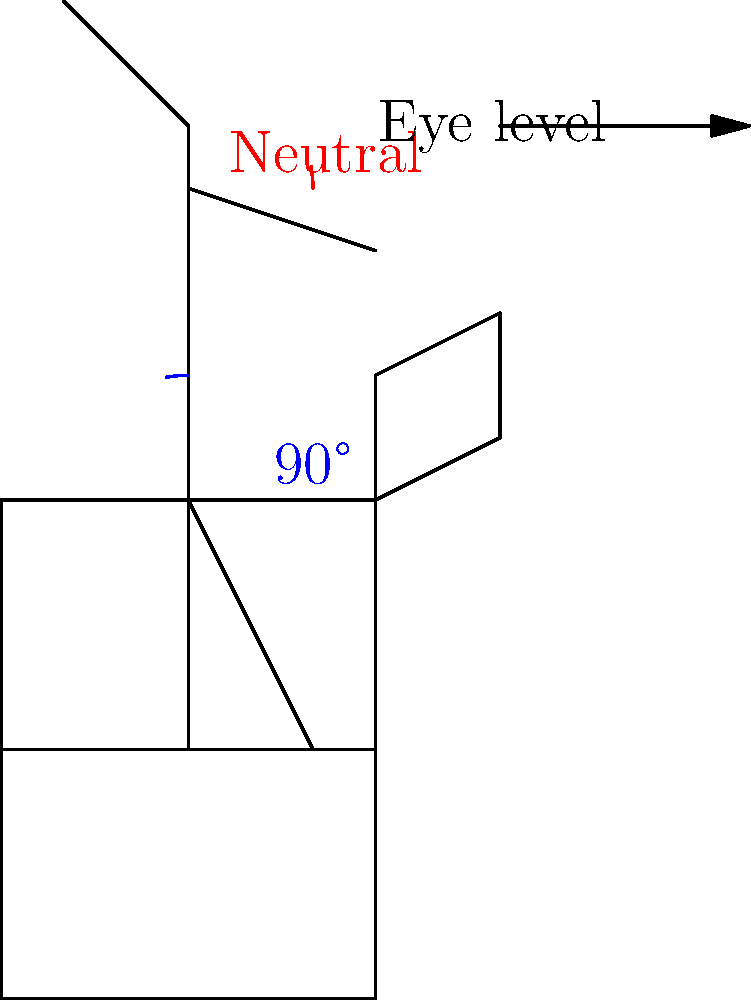As a retired English teacher who enjoys reading classic literature, you understand the importance of maintaining proper posture while engrossed in a book. Based on the diagram, which depicts ideal reading posture, what are the two key angles that should be maintained for optimal biomechanical alignment? To understand the proper posture for reading, let's analyze the diagram step-by-step:

1. Seated position: The figure is seated with the back against the chair for support.

2. Lower body alignment: The hips and knees are bent at approximately 90 degrees, as indicated by the blue angle in the diagram. This position helps distribute weight evenly and reduces strain on the lower back.

3. Spine alignment: The spine is straight and supported by the chair back, maintaining its natural curves.

4. Head position: The head is in a neutral position, with the neck at a slight forward angle (indicated by the red angle). This allows for a relaxed viewing of the book without straining the neck muscles.

5. Book position: The book is held at eye level, reducing the need to tilt the head downward excessively.

The two key angles highlighted in the diagram are:

a) The 90-degree angle at the hips and knees (blue)
b) The slight forward tilt of the head, maintaining a neutral neck position (red)

These angles are crucial for maintaining proper biomechanical alignment while reading, as they help distribute weight evenly, reduce strain on the spine and neck, and allow for comfortable, extended reading sessions without causing undue fatigue or potential long-term postural issues.
Answer: 90-degree hip/knee angle and neutral neck position 